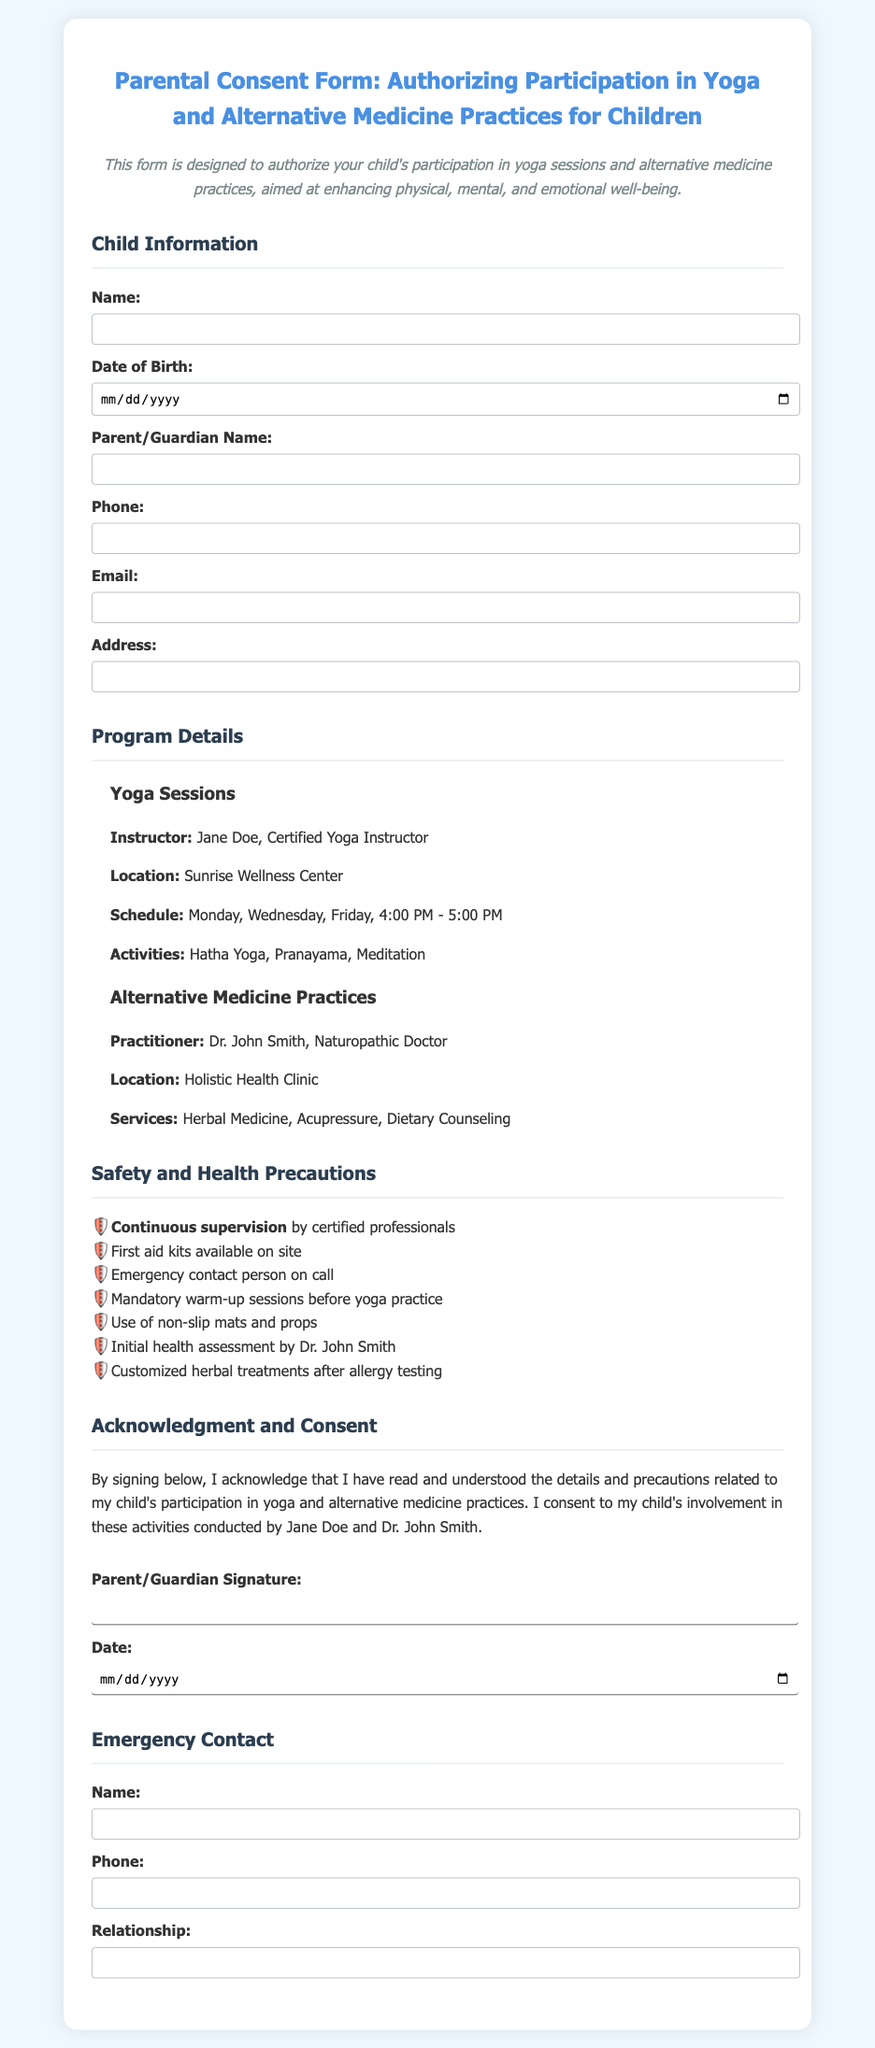What is the title of the document? The title is mentioned at the top of the document and states the subject matter.
Answer: Parental Consent Form: Authorizing Participation in Yoga and Alternative Medicine Practices for Children Who is the yoga instructor? The document lists the name of the instructor under the Yoga Sessions section.
Answer: Jane Doe What are the days of the week for the yoga sessions? The schedule for the yoga sessions specifies the days of participation.
Answer: Monday, Wednesday, Friday What services are provided by the alternative medicine practitioner? The document lists the services offered under the Alternative Medicine Practices section.
Answer: Herbal Medicine, Acupressure, Dietary Counseling Who is responsible for assessing initial health? The practitioner responsible for initial health assessment is mentioned in the Safety and Health Precautions section.
Answer: Dr. John Smith What is the required parental action at the end of the document? The document describes the action that parents need to take to show their agreement to the participation.
Answer: Signing the consent form What is emphasized for the safety precautions? The document outlines key safety measures before participation.
Answer: Continuous supervision What is the relationship of the emergency contact? The document requests information about the emergency contact's relationship to the child.
Answer: Relationship 